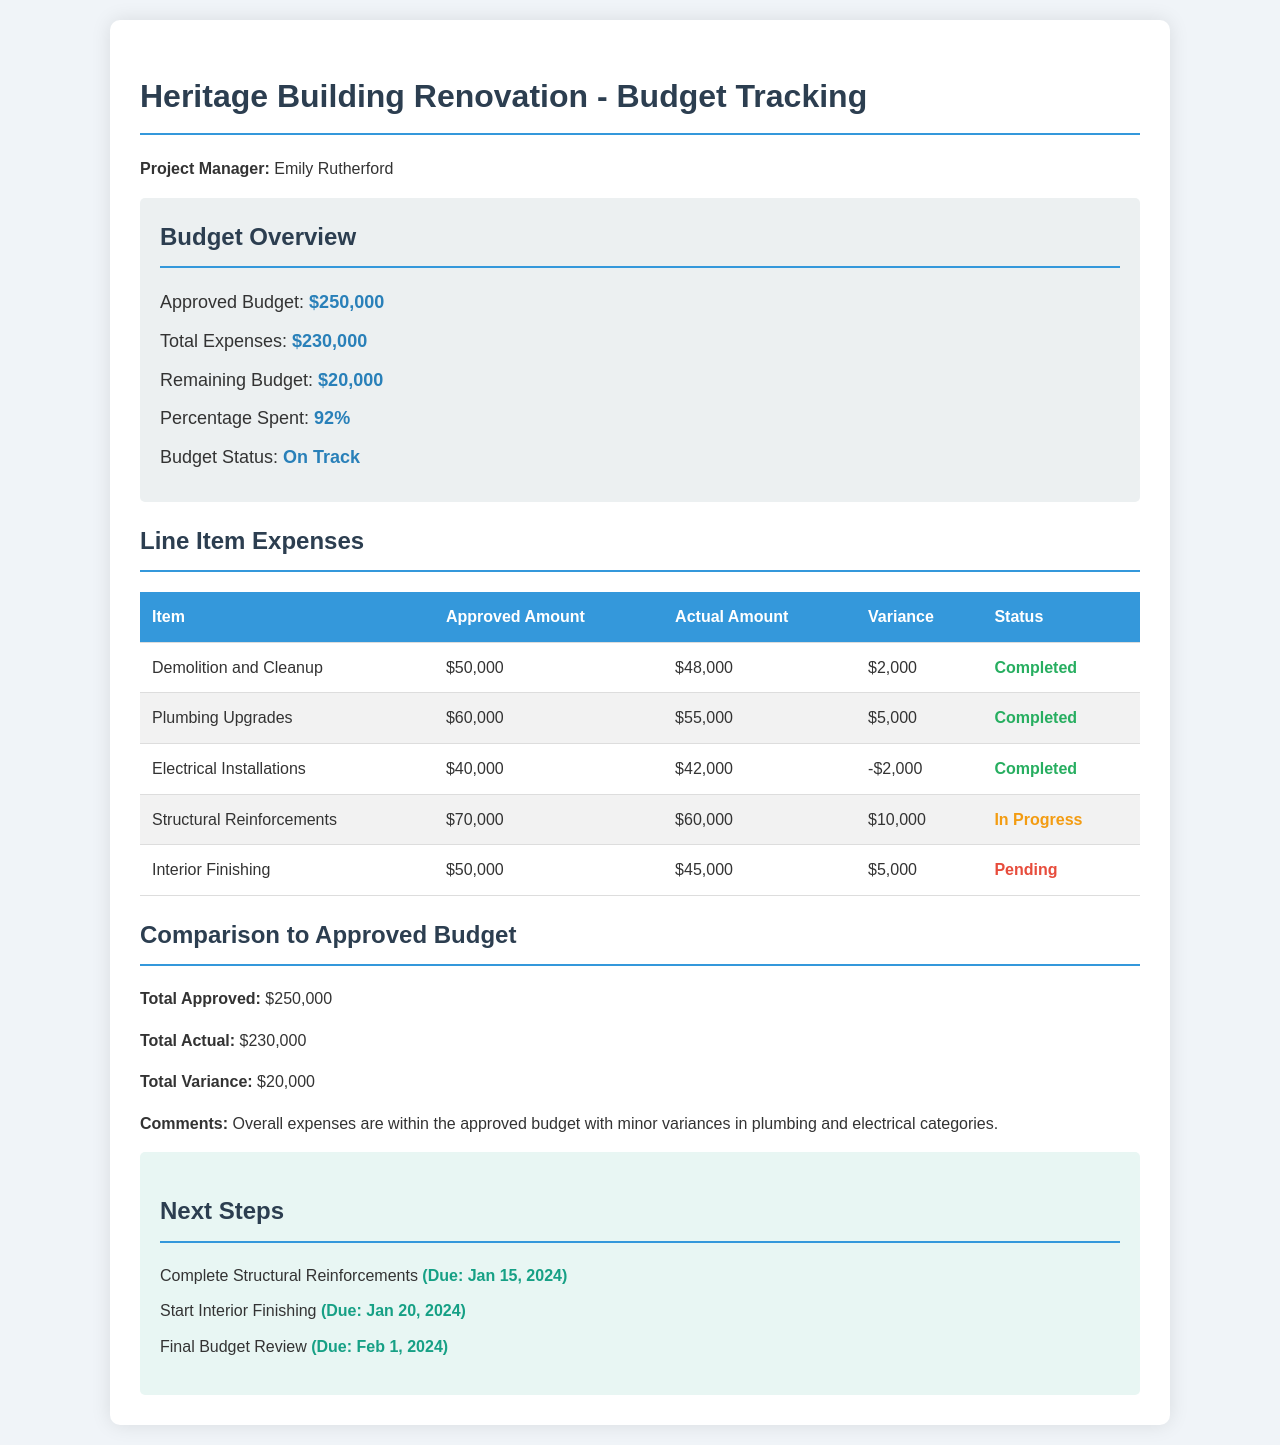What is the approved budget? The approved budget is stated in the budget overview section of the document.
Answer: $250,000 What is the total amount spent so far? The total expenses are listed under the budget overview section.
Answer: $230,000 How much is the remaining budget? The remaining budget is also mentioned in the budget overview section.
Answer: $20,000 What is the status of the plumbing upgrades? The status is provided in the line item expenses table.
Answer: Completed What is the variance for the electrical installations? The variance is detailed in the line item expenses table as the difference between actual and approved amounts.
Answer: -$2,000 How many items are marked as "In Progress"? The line item expenses table indicates the status of each item.
Answer: 1 What category has the highest approved amount? By comparing the approved amounts in the line item expenses table, we can identify the category with the highest amount.
Answer: Structural Reinforcements When is the final budget review due? The due date is listed in the next steps section of the document.
Answer: Feb 1, 2024 What is the overall budget status? The budget status is summarized in the budget overview section.
Answer: On Track 